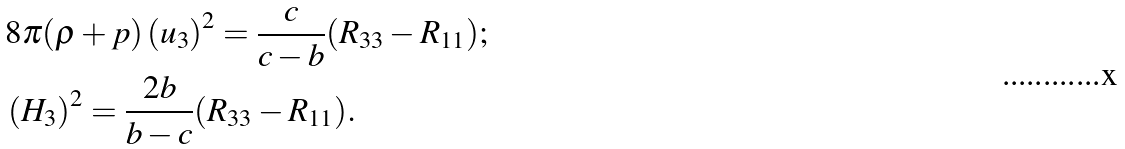<formula> <loc_0><loc_0><loc_500><loc_500>& 8 \pi ( \rho + p ) \left ( u _ { 3 } \right ) ^ { 2 } = \frac { c } { c - b } ( R _ { 3 3 } - R _ { 1 1 } ) ; \\ & \left ( H _ { 3 } \right ) ^ { 2 } = \frac { 2 b } { b - c } ( R _ { 3 3 } - R _ { 1 1 } ) .</formula> 